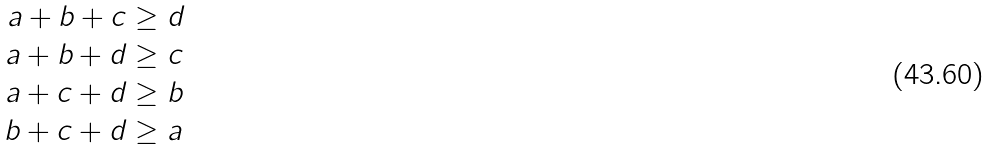Convert formula to latex. <formula><loc_0><loc_0><loc_500><loc_500>a + b + c & \geq d \\ a + b + d & \geq c \\ a + c + d & \geq b \\ b + c + d & \geq a</formula> 